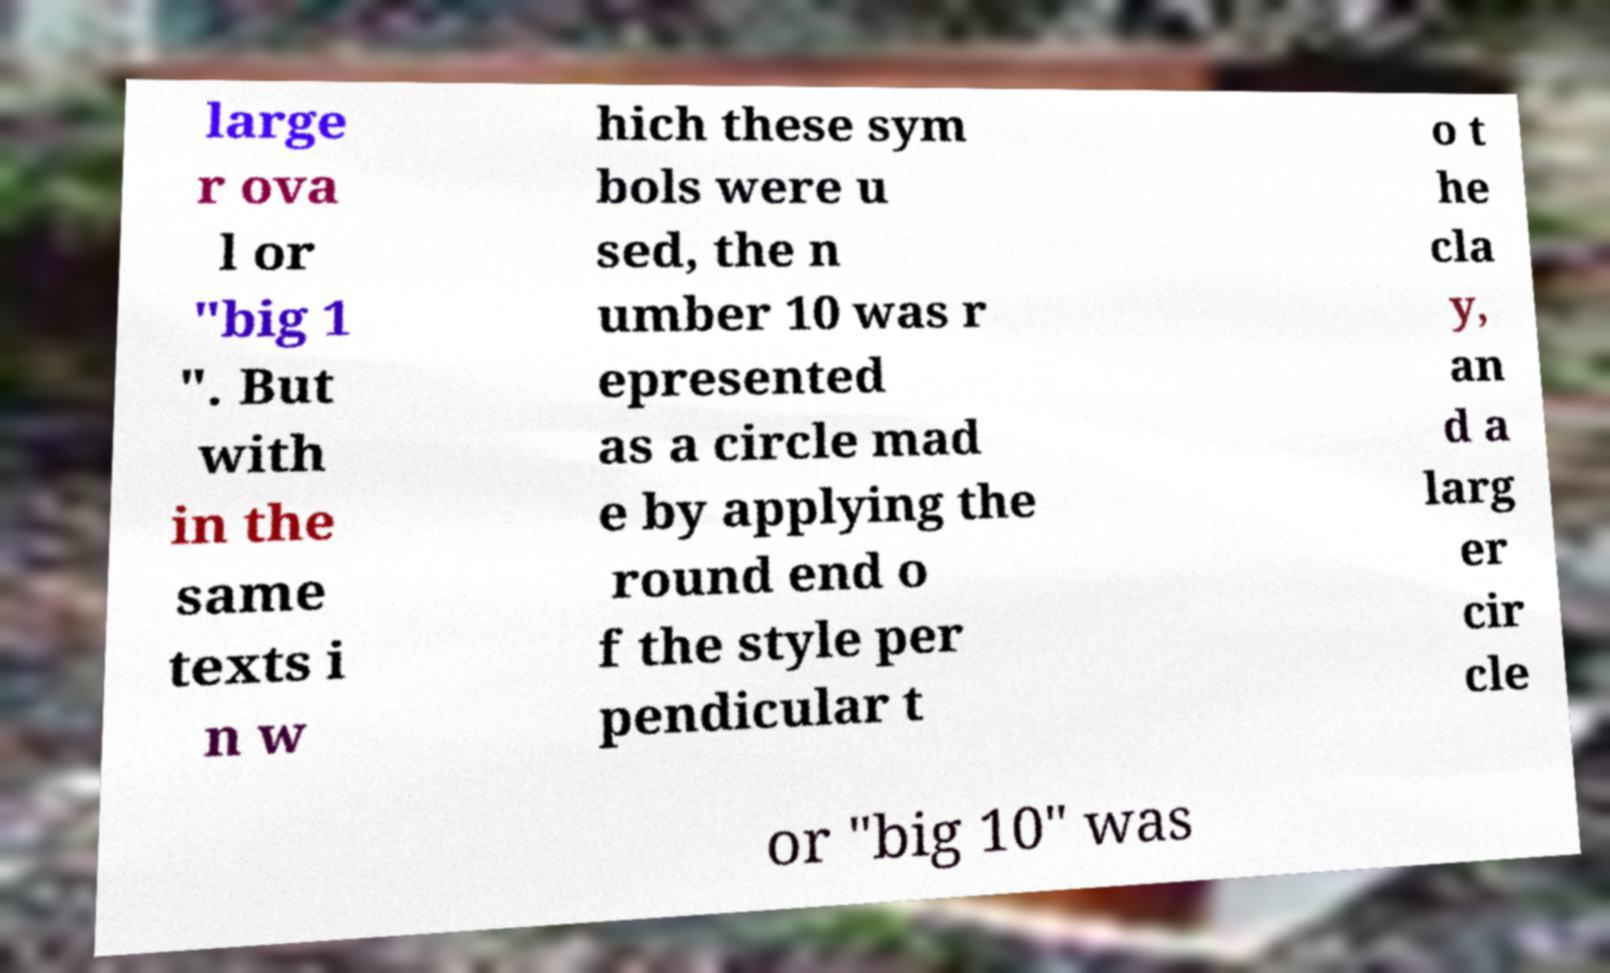Can you read and provide the text displayed in the image?This photo seems to have some interesting text. Can you extract and type it out for me? large r ova l or "big 1 ". But with in the same texts i n w hich these sym bols were u sed, the n umber 10 was r epresented as a circle mad e by applying the round end o f the style per pendicular t o t he cla y, an d a larg er cir cle or "big 10" was 